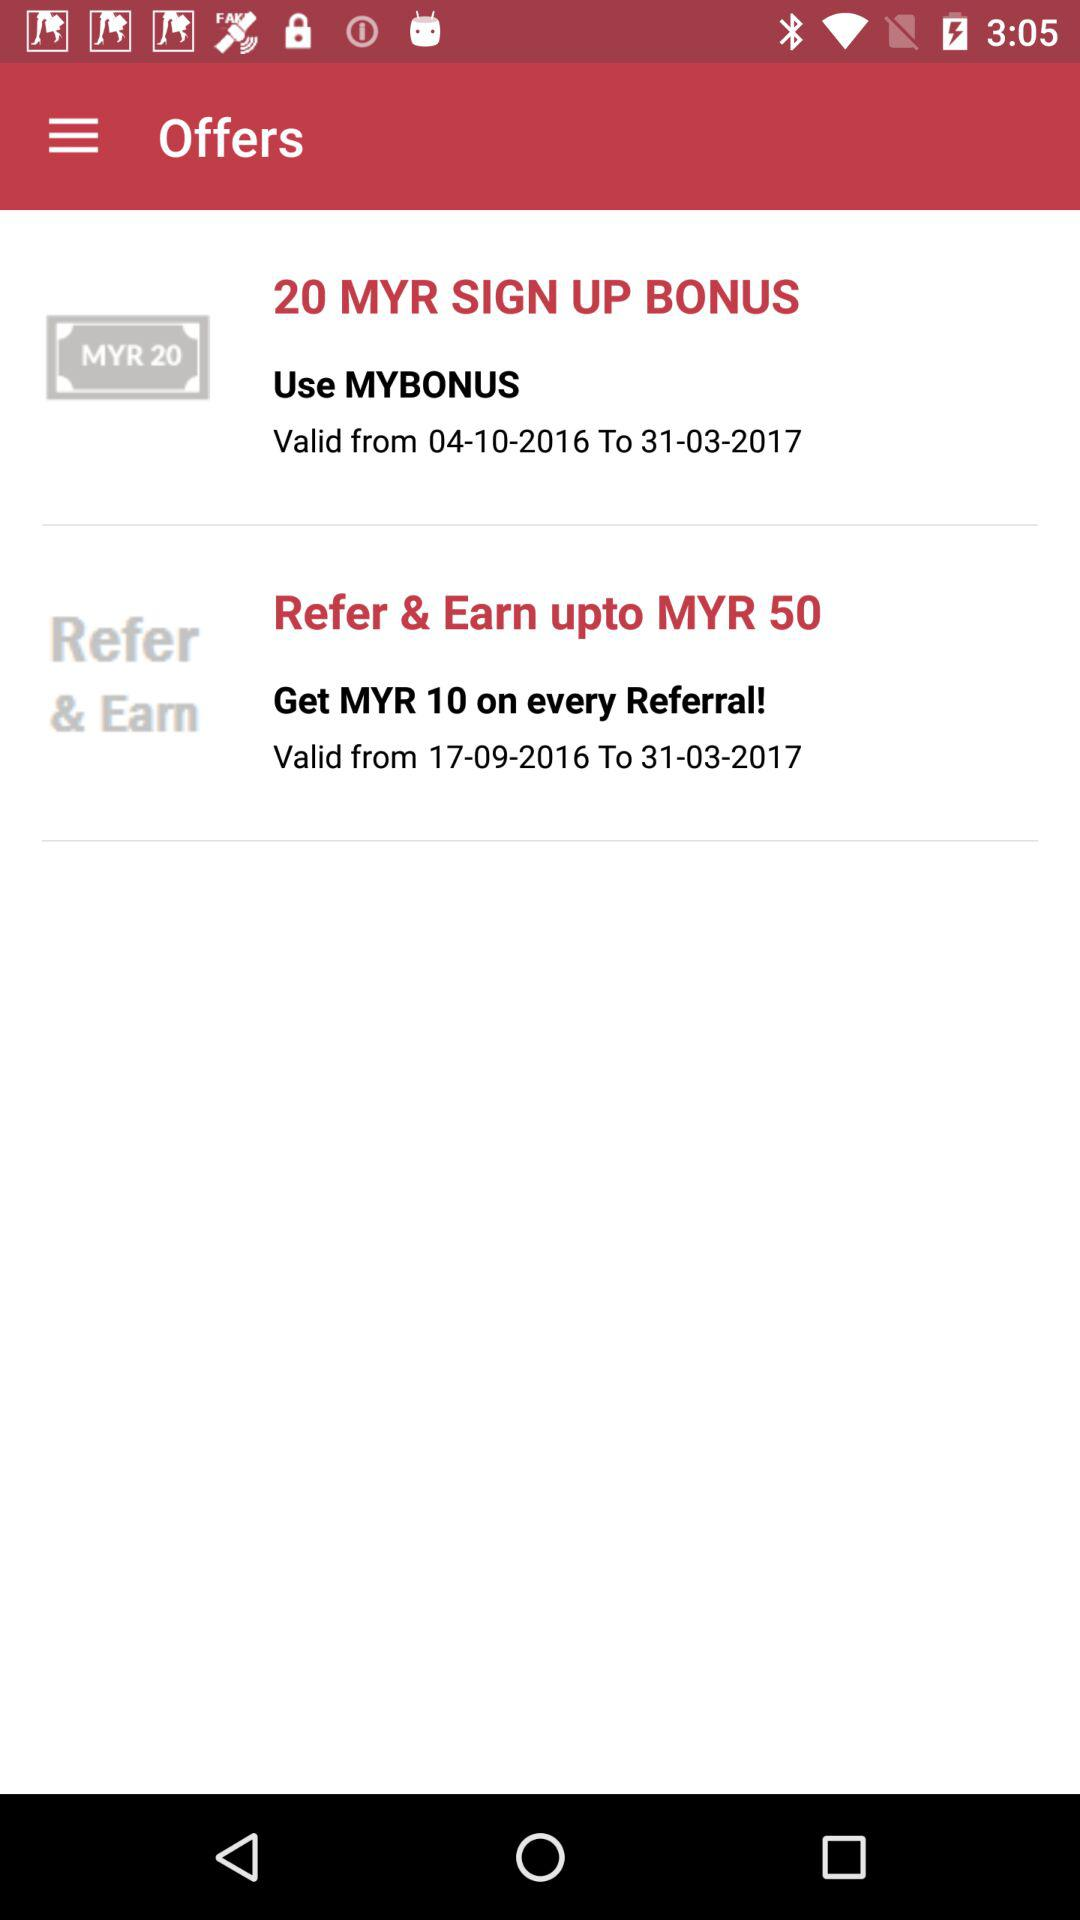How many MYR more is the second offer than the first offer?
Answer the question using a single word or phrase. 30 